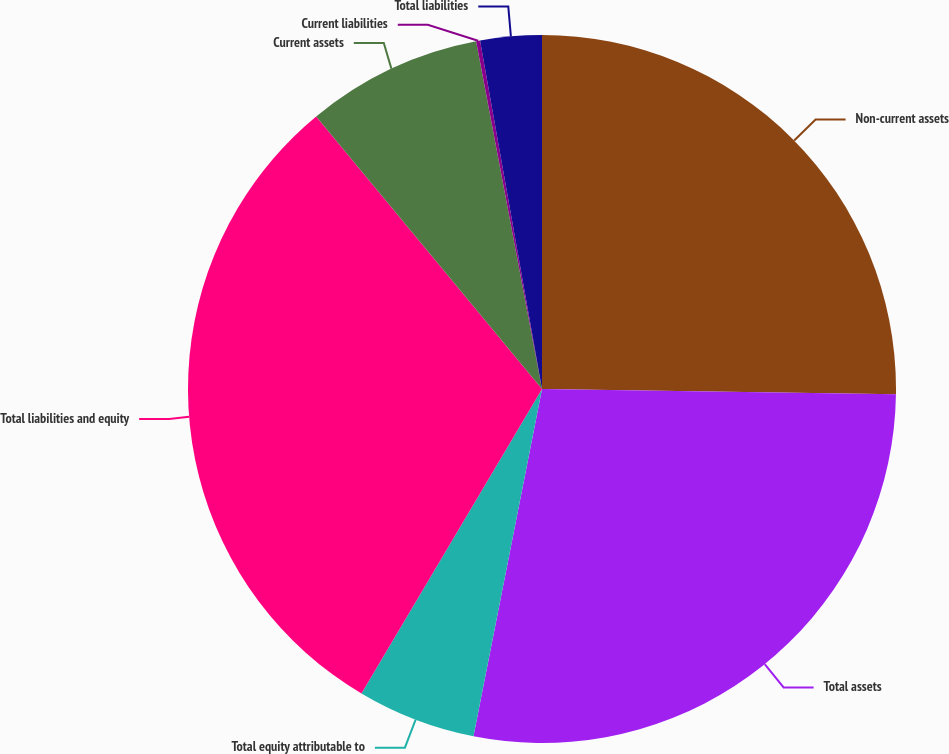Convert chart. <chart><loc_0><loc_0><loc_500><loc_500><pie_chart><fcel>Non-current assets<fcel>Total assets<fcel>Total equity attributable to<fcel>Total liabilities and equity<fcel>Current assets<fcel>Current liabilities<fcel>Total liabilities<nl><fcel>25.24%<fcel>27.86%<fcel>5.42%<fcel>30.47%<fcel>8.03%<fcel>0.18%<fcel>2.8%<nl></chart> 